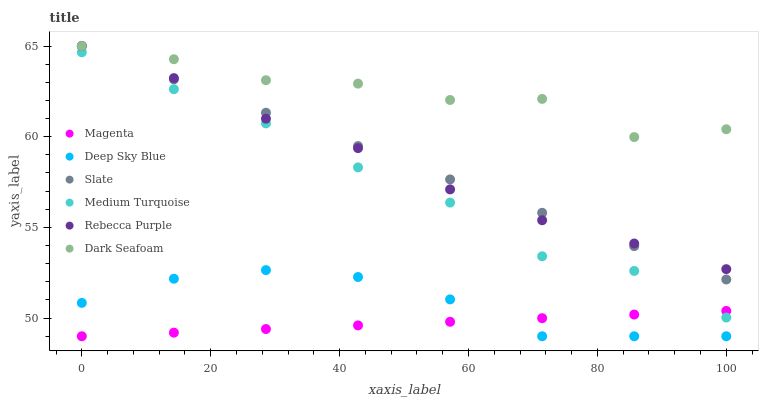Does Magenta have the minimum area under the curve?
Answer yes or no. Yes. Does Dark Seafoam have the maximum area under the curve?
Answer yes or no. Yes. Does Slate have the minimum area under the curve?
Answer yes or no. No. Does Slate have the maximum area under the curve?
Answer yes or no. No. Is Slate the smoothest?
Answer yes or no. Yes. Is Dark Seafoam the roughest?
Answer yes or no. Yes. Is Dark Seafoam the smoothest?
Answer yes or no. No. Is Slate the roughest?
Answer yes or no. No. Does Deep Sky Blue have the lowest value?
Answer yes or no. Yes. Does Slate have the lowest value?
Answer yes or no. No. Does Rebecca Purple have the highest value?
Answer yes or no. Yes. Does Deep Sky Blue have the highest value?
Answer yes or no. No. Is Deep Sky Blue less than Dark Seafoam?
Answer yes or no. Yes. Is Dark Seafoam greater than Magenta?
Answer yes or no. Yes. Does Medium Turquoise intersect Magenta?
Answer yes or no. Yes. Is Medium Turquoise less than Magenta?
Answer yes or no. No. Is Medium Turquoise greater than Magenta?
Answer yes or no. No. Does Deep Sky Blue intersect Dark Seafoam?
Answer yes or no. No. 